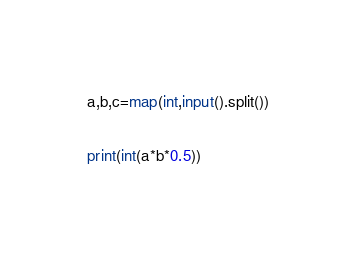Convert code to text. <code><loc_0><loc_0><loc_500><loc_500><_Python_>a,b,c=map(int,input().split())

print(int(a*b*0.5))</code> 